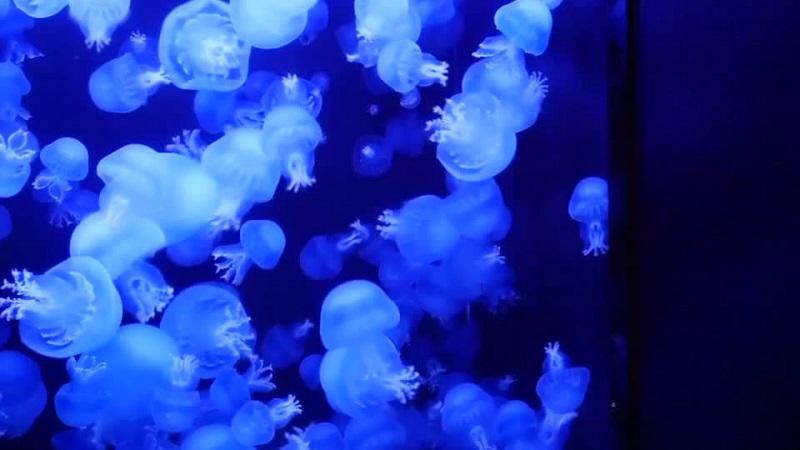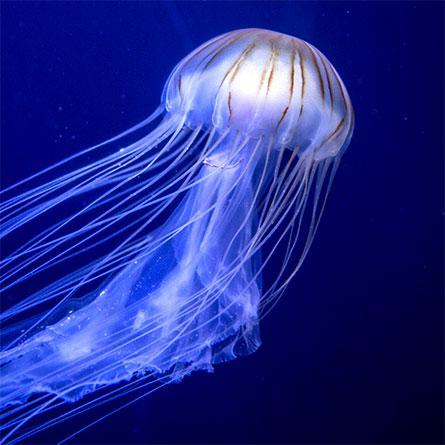The first image is the image on the left, the second image is the image on the right. For the images shown, is this caption "The left image contains at least three jelly fish." true? Answer yes or no. Yes. 